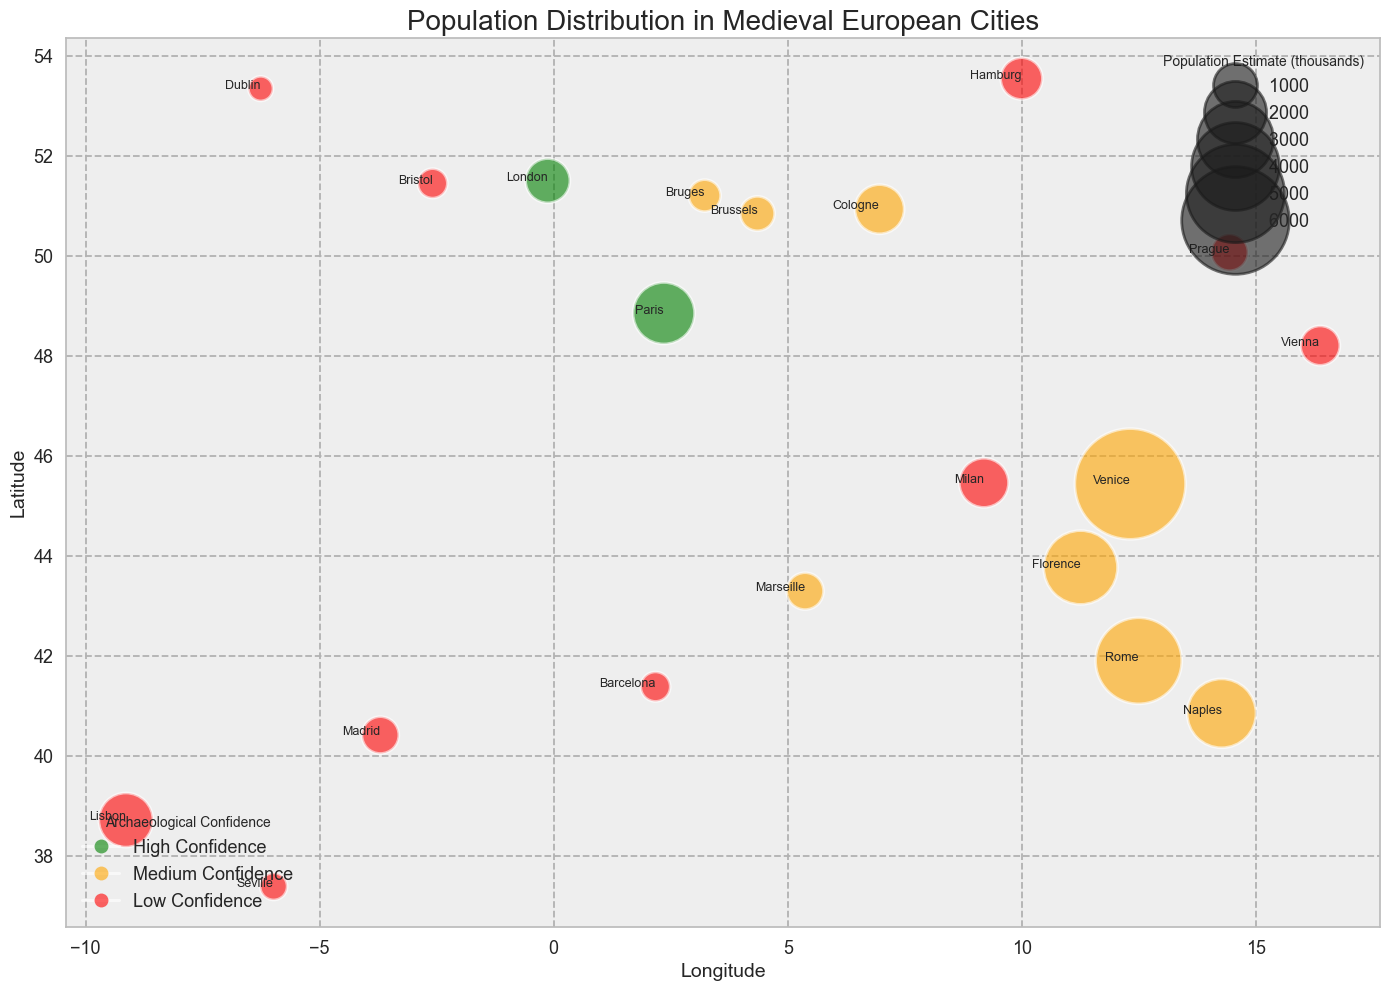What is the city with the highest population estimate? Locate the city with the largest bubble on the chart, which represents the highest population estimate. The largest bubble is associated with Venice.
Answer: Venice Identify the city with the lowest confidence level and highest population estimate. Look for red bubbles (low confidence level) and compare their sizes. Milan is the largest among the red bubbles, indicating it has the highest population estimate within the low confidence category.
Answer: Milan Which city is positioned furthest to the east? Identify the city with the highest longitude value (furthest to the right on the x-axis). That city is Vienna.
Answer: Vienna Compare the population estimates of Florence and Rome. Which city has a larger population? Compare the sizes of the bubbles assigned to Florence and Rome. The bubble for Rome is larger, indicating a higher population estimate.
Answer: Rome Order the cities of London, Paris, and Cologne by population estimate from highest to lowest. Compare the sizes of the bubbles for these three cities. Paris has the largest bubble, followed by London, with Cologne having the smallest bubble.
Answer: Paris, London, Cologne What's the combined population estimate of the cities with high archaeological confidence? Identify the green bubbles (high confidence). Sum the populations of London (18000) and Paris (25000). The combined population is 18000 + 25000 = 43000.
Answer: 43000 Which city has a medium archaeological confidence and is closest to Rome in latitude? Look for orange bubbles (medium confidence) close to Rome’s latitude (41.9028). Naples (40.8518) is the closest in latitude among medium confidence cities.
Answer: Naples Which city further west has a higher population estimate: Barcelona or Lisbon? Compare the bubble sizes of Barcelona and Lisbon. Lisbon's bubble is larger than Barcelona's.
Answer: Lisbon How many cities have a population estimate between 10,000 and 20,000? Identify the cities with bubble sizes between the corresponding range. They are Dublin, Bruges, Brussels, Vienna, Hamburg, Prague, Madrid, Bristol, and Cologne. Count these cities: total is 9.
Answer: 9 What’s the color representing archaeological confidence for the city of Florence? Locate Florence and observe the color of its bubble. The bubble is orange, indicating medium confidence.
Answer: Orange 